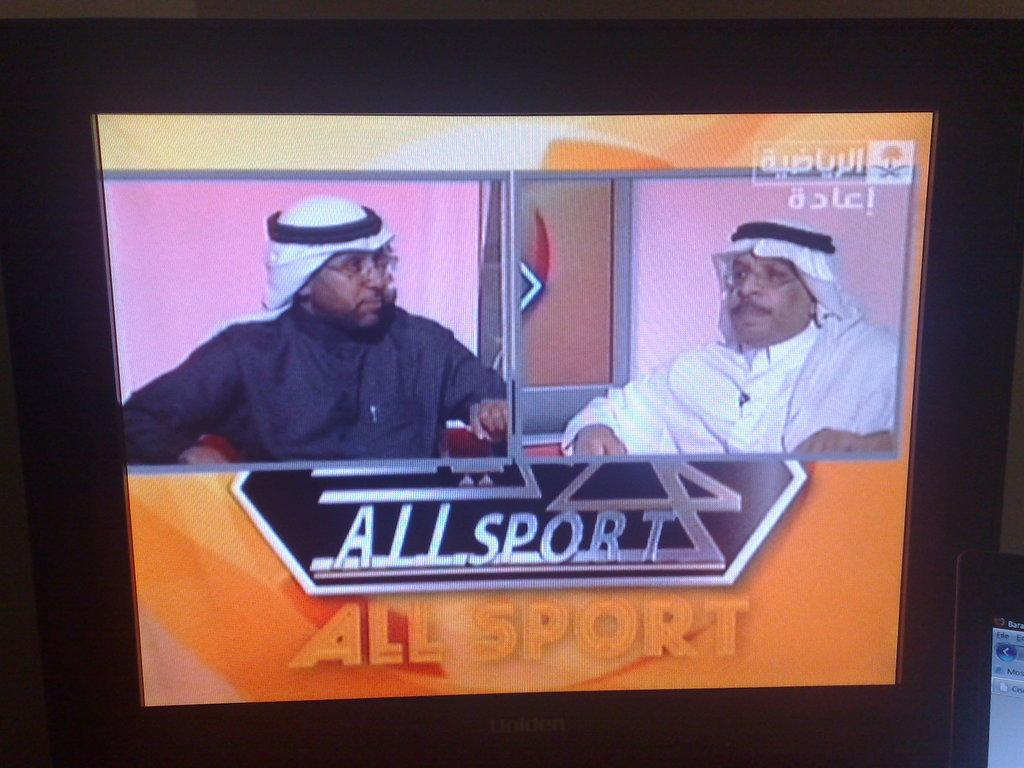<image>
Write a terse but informative summary of the picture. two arab dressed men speaking on All Sport news 